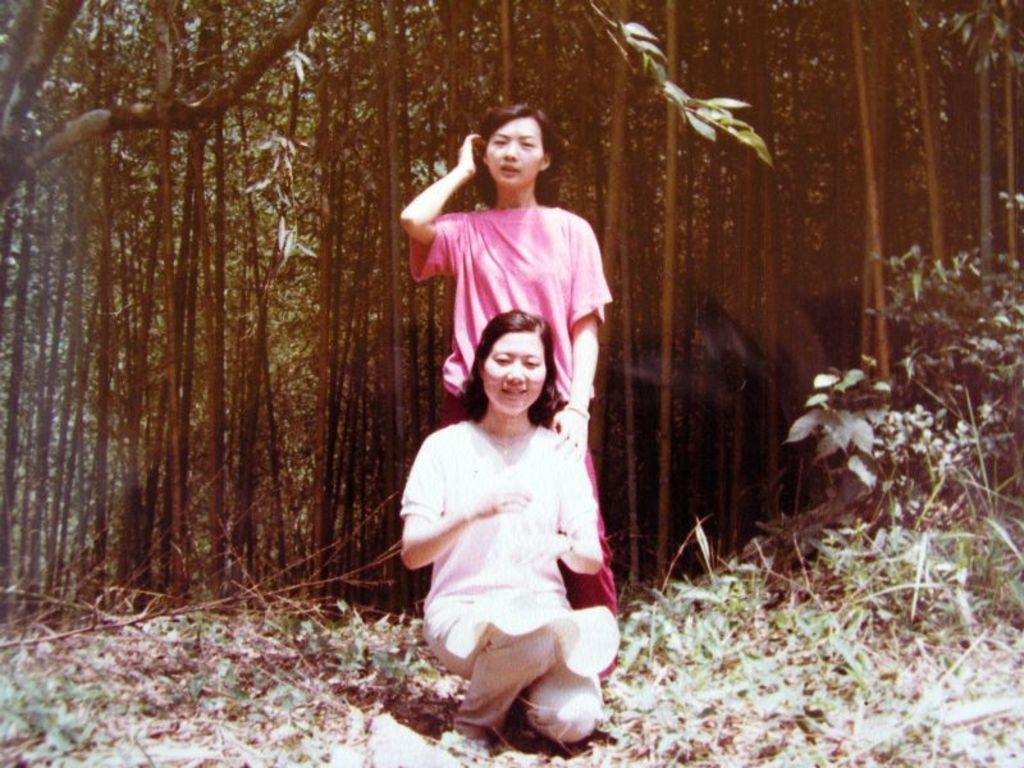In one or two sentences, can you explain what this image depicts? In this image we can see two women on the ground, in the background there are some trees and grass on the ground. 